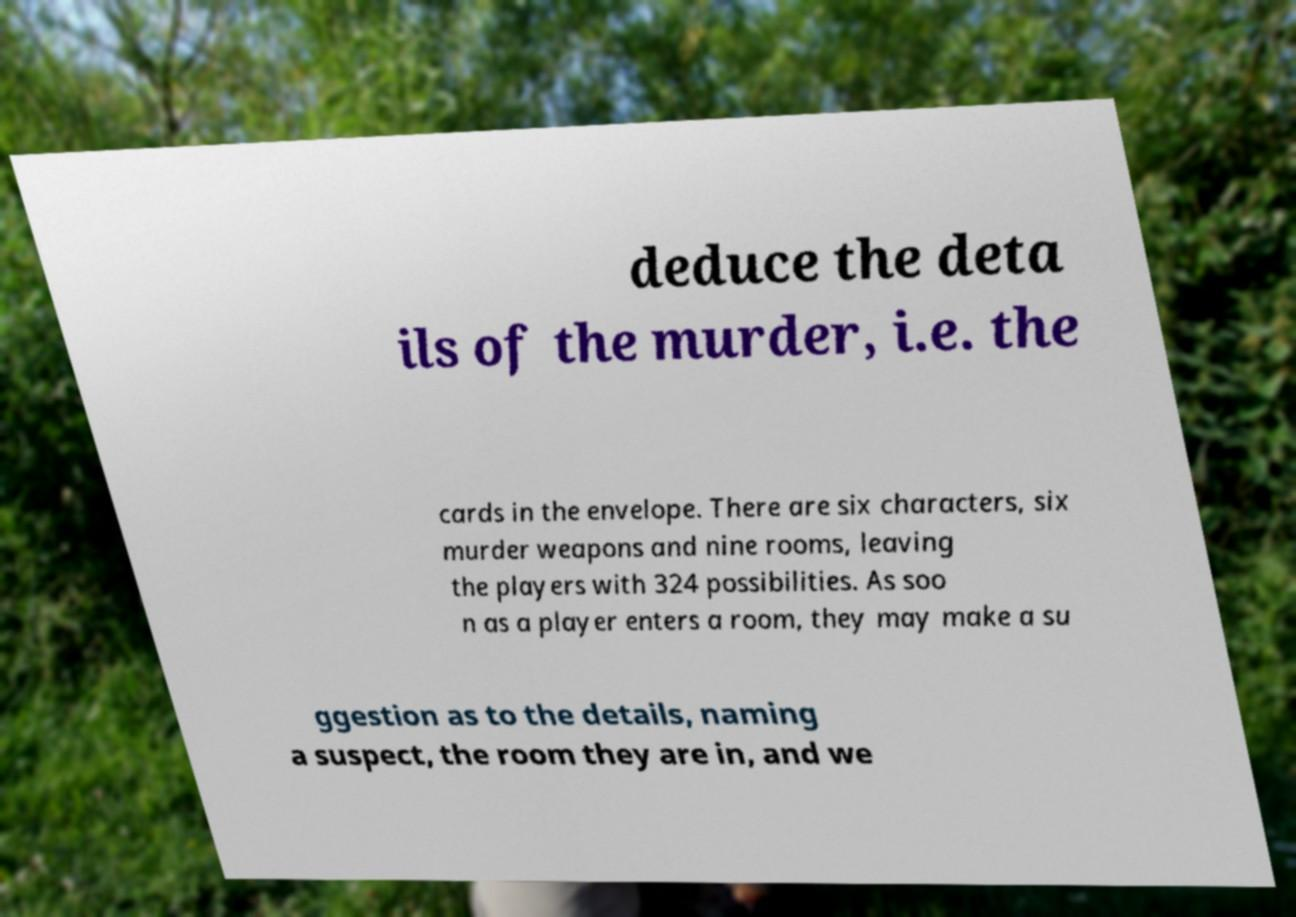Could you assist in decoding the text presented in this image and type it out clearly? deduce the deta ils of the murder, i.e. the cards in the envelope. There are six characters, six murder weapons and nine rooms, leaving the players with 324 possibilities. As soo n as a player enters a room, they may make a su ggestion as to the details, naming a suspect, the room they are in, and we 